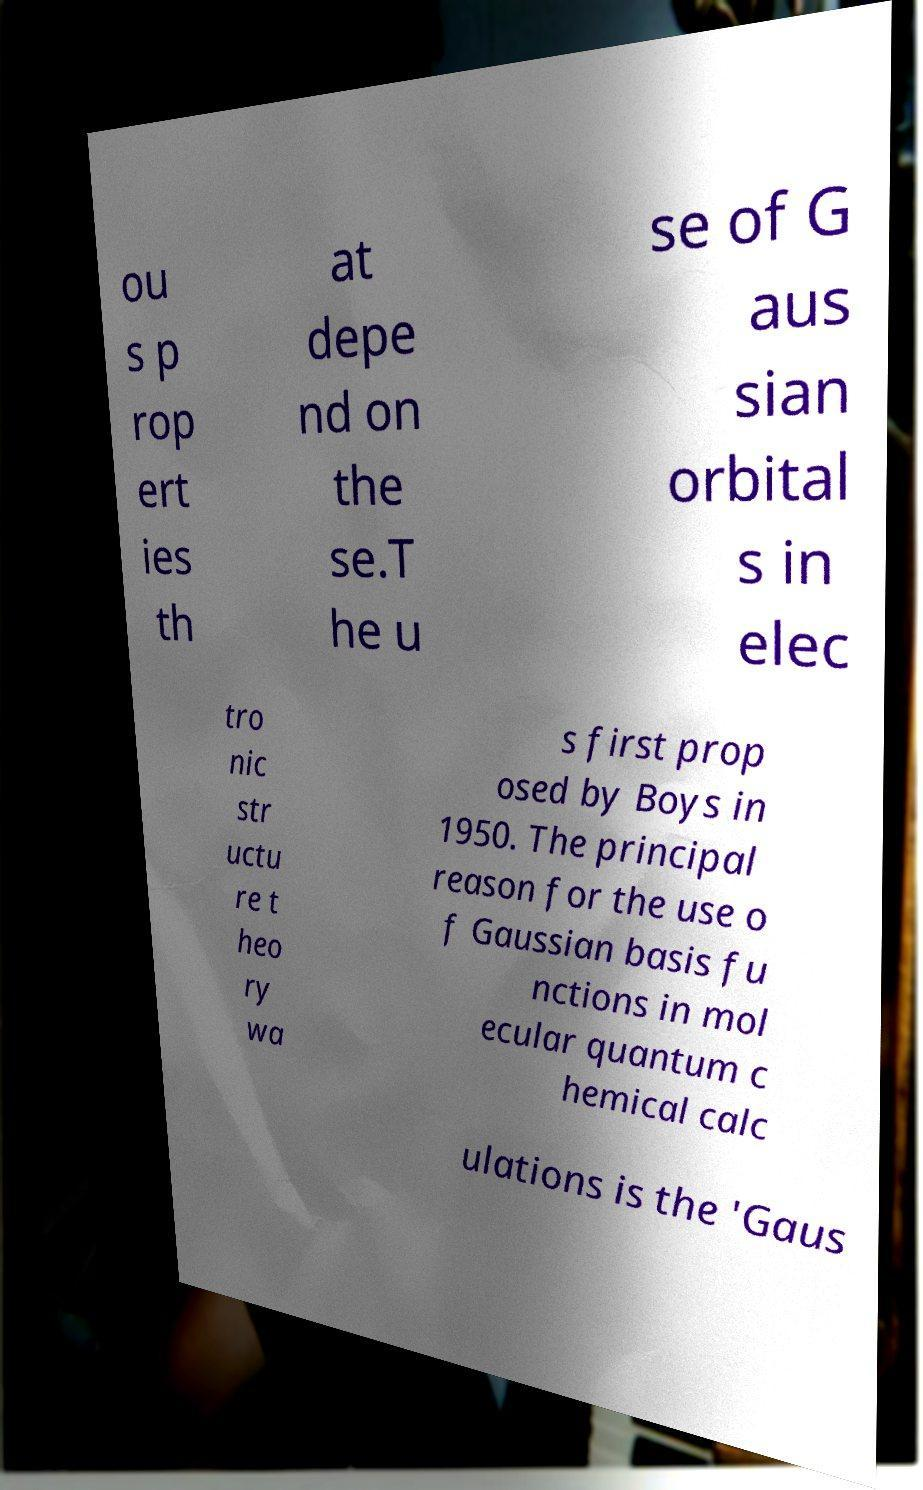I need the written content from this picture converted into text. Can you do that? ou s p rop ert ies th at depe nd on the se.T he u se of G aus sian orbital s in elec tro nic str uctu re t heo ry wa s first prop osed by Boys in 1950. The principal reason for the use o f Gaussian basis fu nctions in mol ecular quantum c hemical calc ulations is the 'Gaus 